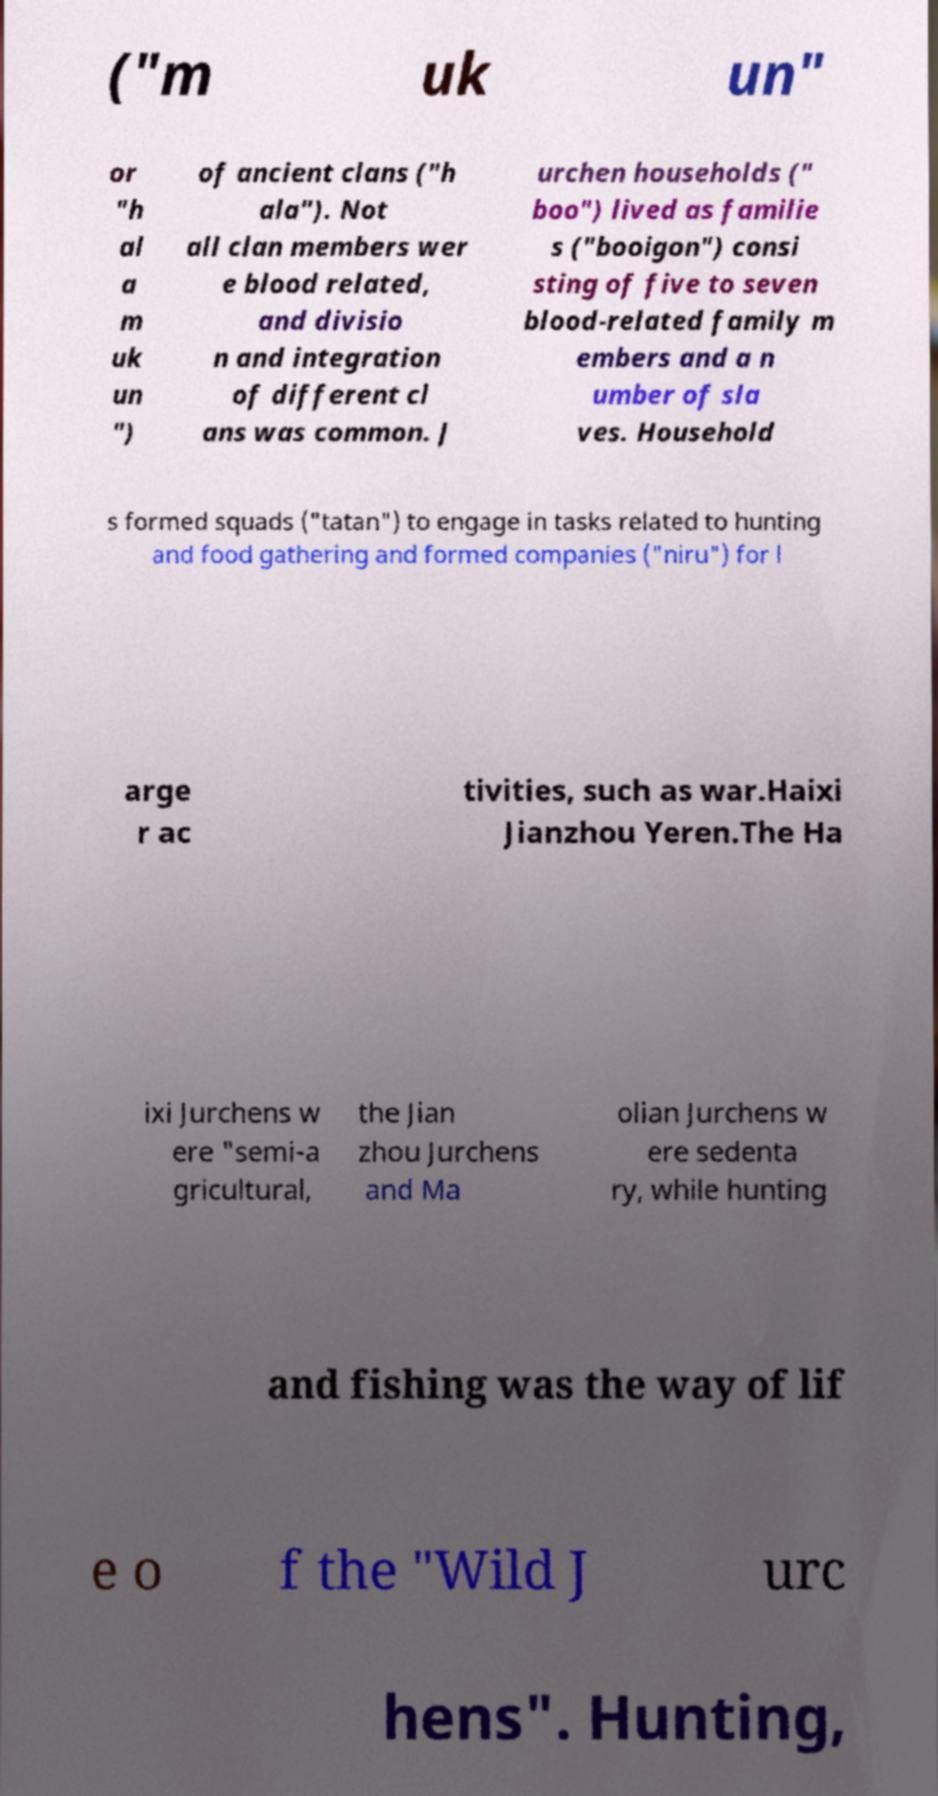Please identify and transcribe the text found in this image. ("m uk un" or "h al a m uk un ") of ancient clans ("h ala"). Not all clan members wer e blood related, and divisio n and integration of different cl ans was common. J urchen households (" boo") lived as familie s ("booigon") consi sting of five to seven blood-related family m embers and a n umber of sla ves. Household s formed squads ("tatan") to engage in tasks related to hunting and food gathering and formed companies ("niru") for l arge r ac tivities, such as war.Haixi Jianzhou Yeren.The Ha ixi Jurchens w ere "semi-a gricultural, the Jian zhou Jurchens and Ma olian Jurchens w ere sedenta ry, while hunting and fishing was the way of lif e o f the "Wild J urc hens". Hunting, 